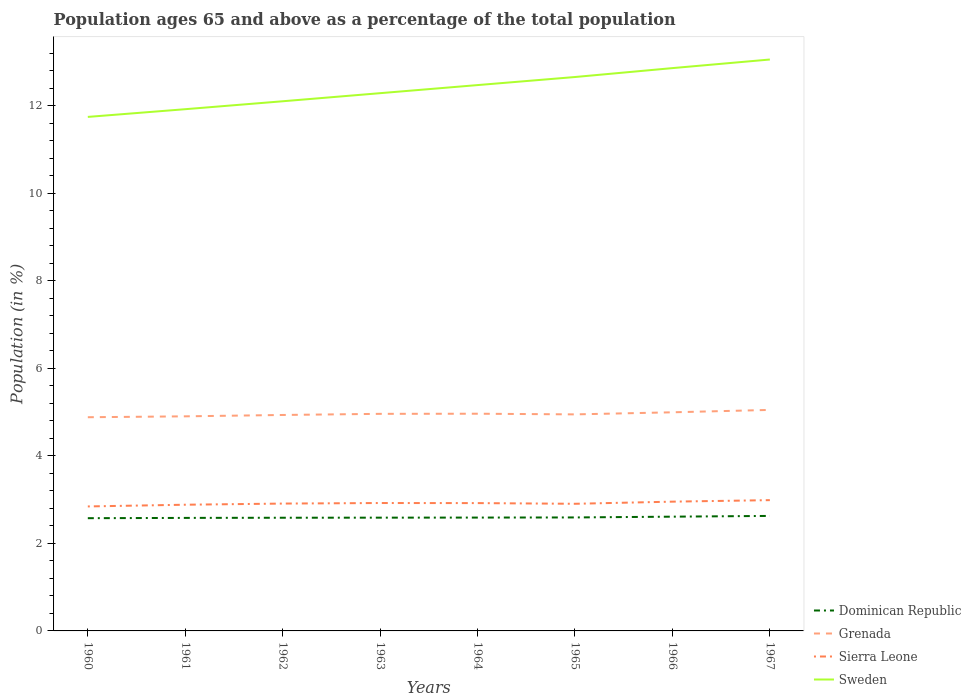How many different coloured lines are there?
Offer a very short reply. 4. Does the line corresponding to Sierra Leone intersect with the line corresponding to Grenada?
Your response must be concise. No. Across all years, what is the maximum percentage of the population ages 65 and above in Grenada?
Keep it short and to the point. 4.88. What is the total percentage of the population ages 65 and above in Sweden in the graph?
Ensure brevity in your answer.  -0.18. What is the difference between the highest and the second highest percentage of the population ages 65 and above in Sweden?
Offer a very short reply. 1.31. Is the percentage of the population ages 65 and above in Sierra Leone strictly greater than the percentage of the population ages 65 and above in Dominican Republic over the years?
Provide a succinct answer. No. How many lines are there?
Provide a short and direct response. 4. How many years are there in the graph?
Keep it short and to the point. 8. Are the values on the major ticks of Y-axis written in scientific E-notation?
Keep it short and to the point. No. Does the graph contain any zero values?
Your response must be concise. No. What is the title of the graph?
Your answer should be very brief. Population ages 65 and above as a percentage of the total population. What is the label or title of the X-axis?
Offer a terse response. Years. What is the label or title of the Y-axis?
Offer a terse response. Population (in %). What is the Population (in %) in Dominican Republic in 1960?
Your answer should be compact. 2.58. What is the Population (in %) in Grenada in 1960?
Keep it short and to the point. 4.88. What is the Population (in %) in Sierra Leone in 1960?
Your answer should be very brief. 2.85. What is the Population (in %) of Sweden in 1960?
Provide a succinct answer. 11.75. What is the Population (in %) of Dominican Republic in 1961?
Ensure brevity in your answer.  2.58. What is the Population (in %) of Grenada in 1961?
Provide a succinct answer. 4.9. What is the Population (in %) in Sierra Leone in 1961?
Your response must be concise. 2.88. What is the Population (in %) of Sweden in 1961?
Provide a succinct answer. 11.92. What is the Population (in %) of Dominican Republic in 1962?
Provide a succinct answer. 2.59. What is the Population (in %) of Grenada in 1962?
Offer a very short reply. 4.94. What is the Population (in %) in Sierra Leone in 1962?
Offer a terse response. 2.91. What is the Population (in %) of Sweden in 1962?
Make the answer very short. 12.11. What is the Population (in %) in Dominican Republic in 1963?
Your answer should be compact. 2.59. What is the Population (in %) of Grenada in 1963?
Keep it short and to the point. 4.96. What is the Population (in %) in Sierra Leone in 1963?
Keep it short and to the point. 2.92. What is the Population (in %) in Sweden in 1963?
Your answer should be very brief. 12.29. What is the Population (in %) in Dominican Republic in 1964?
Make the answer very short. 2.59. What is the Population (in %) in Grenada in 1964?
Your answer should be very brief. 4.96. What is the Population (in %) of Sierra Leone in 1964?
Your response must be concise. 2.92. What is the Population (in %) of Sweden in 1964?
Your answer should be very brief. 12.48. What is the Population (in %) in Dominican Republic in 1965?
Make the answer very short. 2.59. What is the Population (in %) of Grenada in 1965?
Provide a short and direct response. 4.95. What is the Population (in %) in Sierra Leone in 1965?
Ensure brevity in your answer.  2.91. What is the Population (in %) of Sweden in 1965?
Make the answer very short. 12.66. What is the Population (in %) in Dominican Republic in 1966?
Your response must be concise. 2.61. What is the Population (in %) in Grenada in 1966?
Provide a succinct answer. 5. What is the Population (in %) of Sierra Leone in 1966?
Provide a short and direct response. 2.95. What is the Population (in %) of Sweden in 1966?
Keep it short and to the point. 12.86. What is the Population (in %) of Dominican Republic in 1967?
Offer a very short reply. 2.63. What is the Population (in %) in Grenada in 1967?
Provide a succinct answer. 5.05. What is the Population (in %) of Sierra Leone in 1967?
Keep it short and to the point. 2.99. What is the Population (in %) in Sweden in 1967?
Provide a succinct answer. 13.06. Across all years, what is the maximum Population (in %) of Dominican Republic?
Provide a short and direct response. 2.63. Across all years, what is the maximum Population (in %) in Grenada?
Your answer should be very brief. 5.05. Across all years, what is the maximum Population (in %) in Sierra Leone?
Your answer should be very brief. 2.99. Across all years, what is the maximum Population (in %) in Sweden?
Your answer should be compact. 13.06. Across all years, what is the minimum Population (in %) in Dominican Republic?
Give a very brief answer. 2.58. Across all years, what is the minimum Population (in %) in Grenada?
Ensure brevity in your answer.  4.88. Across all years, what is the minimum Population (in %) of Sierra Leone?
Provide a succinct answer. 2.85. Across all years, what is the minimum Population (in %) in Sweden?
Provide a succinct answer. 11.75. What is the total Population (in %) in Dominican Republic in the graph?
Provide a short and direct response. 20.76. What is the total Population (in %) in Grenada in the graph?
Offer a very short reply. 39.65. What is the total Population (in %) in Sierra Leone in the graph?
Ensure brevity in your answer.  23.34. What is the total Population (in %) in Sweden in the graph?
Provide a succinct answer. 99.13. What is the difference between the Population (in %) in Dominican Republic in 1960 and that in 1961?
Make the answer very short. -0.01. What is the difference between the Population (in %) of Grenada in 1960 and that in 1961?
Make the answer very short. -0.02. What is the difference between the Population (in %) of Sierra Leone in 1960 and that in 1961?
Provide a succinct answer. -0.04. What is the difference between the Population (in %) of Sweden in 1960 and that in 1961?
Give a very brief answer. -0.18. What is the difference between the Population (in %) of Dominican Republic in 1960 and that in 1962?
Offer a terse response. -0.01. What is the difference between the Population (in %) in Grenada in 1960 and that in 1962?
Keep it short and to the point. -0.05. What is the difference between the Population (in %) in Sierra Leone in 1960 and that in 1962?
Your answer should be very brief. -0.07. What is the difference between the Population (in %) of Sweden in 1960 and that in 1962?
Make the answer very short. -0.36. What is the difference between the Population (in %) of Dominican Republic in 1960 and that in 1963?
Keep it short and to the point. -0.01. What is the difference between the Population (in %) in Grenada in 1960 and that in 1963?
Make the answer very short. -0.08. What is the difference between the Population (in %) in Sierra Leone in 1960 and that in 1963?
Ensure brevity in your answer.  -0.08. What is the difference between the Population (in %) in Sweden in 1960 and that in 1963?
Provide a short and direct response. -0.54. What is the difference between the Population (in %) in Dominican Republic in 1960 and that in 1964?
Provide a succinct answer. -0.01. What is the difference between the Population (in %) of Grenada in 1960 and that in 1964?
Provide a short and direct response. -0.08. What is the difference between the Population (in %) in Sierra Leone in 1960 and that in 1964?
Give a very brief answer. -0.08. What is the difference between the Population (in %) of Sweden in 1960 and that in 1964?
Your answer should be compact. -0.73. What is the difference between the Population (in %) of Dominican Republic in 1960 and that in 1965?
Provide a short and direct response. -0.02. What is the difference between the Population (in %) in Grenada in 1960 and that in 1965?
Offer a very short reply. -0.07. What is the difference between the Population (in %) in Sierra Leone in 1960 and that in 1965?
Give a very brief answer. -0.06. What is the difference between the Population (in %) in Sweden in 1960 and that in 1965?
Offer a very short reply. -0.91. What is the difference between the Population (in %) in Dominican Republic in 1960 and that in 1966?
Make the answer very short. -0.03. What is the difference between the Population (in %) of Grenada in 1960 and that in 1966?
Provide a short and direct response. -0.11. What is the difference between the Population (in %) of Sierra Leone in 1960 and that in 1966?
Offer a terse response. -0.11. What is the difference between the Population (in %) of Sweden in 1960 and that in 1966?
Your response must be concise. -1.12. What is the difference between the Population (in %) of Dominican Republic in 1960 and that in 1967?
Offer a terse response. -0.05. What is the difference between the Population (in %) of Grenada in 1960 and that in 1967?
Your answer should be compact. -0.17. What is the difference between the Population (in %) of Sierra Leone in 1960 and that in 1967?
Give a very brief answer. -0.14. What is the difference between the Population (in %) in Sweden in 1960 and that in 1967?
Offer a very short reply. -1.31. What is the difference between the Population (in %) of Dominican Republic in 1961 and that in 1962?
Your answer should be very brief. -0. What is the difference between the Population (in %) of Grenada in 1961 and that in 1962?
Your answer should be very brief. -0.03. What is the difference between the Population (in %) of Sierra Leone in 1961 and that in 1962?
Ensure brevity in your answer.  -0.03. What is the difference between the Population (in %) in Sweden in 1961 and that in 1962?
Make the answer very short. -0.18. What is the difference between the Population (in %) in Dominican Republic in 1961 and that in 1963?
Give a very brief answer. -0.01. What is the difference between the Population (in %) in Grenada in 1961 and that in 1963?
Provide a short and direct response. -0.06. What is the difference between the Population (in %) in Sierra Leone in 1961 and that in 1963?
Keep it short and to the point. -0.04. What is the difference between the Population (in %) of Sweden in 1961 and that in 1963?
Your answer should be very brief. -0.37. What is the difference between the Population (in %) in Dominican Republic in 1961 and that in 1964?
Ensure brevity in your answer.  -0.01. What is the difference between the Population (in %) in Grenada in 1961 and that in 1964?
Make the answer very short. -0.06. What is the difference between the Population (in %) of Sierra Leone in 1961 and that in 1964?
Give a very brief answer. -0.04. What is the difference between the Population (in %) of Sweden in 1961 and that in 1964?
Offer a terse response. -0.55. What is the difference between the Population (in %) of Dominican Republic in 1961 and that in 1965?
Your answer should be very brief. -0.01. What is the difference between the Population (in %) of Grenada in 1961 and that in 1965?
Provide a short and direct response. -0.04. What is the difference between the Population (in %) in Sierra Leone in 1961 and that in 1965?
Make the answer very short. -0.02. What is the difference between the Population (in %) of Sweden in 1961 and that in 1965?
Make the answer very short. -0.74. What is the difference between the Population (in %) in Dominican Republic in 1961 and that in 1966?
Provide a short and direct response. -0.03. What is the difference between the Population (in %) in Grenada in 1961 and that in 1966?
Provide a succinct answer. -0.09. What is the difference between the Population (in %) of Sierra Leone in 1961 and that in 1966?
Your answer should be very brief. -0.07. What is the difference between the Population (in %) in Sweden in 1961 and that in 1966?
Give a very brief answer. -0.94. What is the difference between the Population (in %) in Dominican Republic in 1961 and that in 1967?
Your response must be concise. -0.05. What is the difference between the Population (in %) of Grenada in 1961 and that in 1967?
Offer a terse response. -0.15. What is the difference between the Population (in %) of Sierra Leone in 1961 and that in 1967?
Make the answer very short. -0.1. What is the difference between the Population (in %) in Sweden in 1961 and that in 1967?
Your answer should be compact. -1.14. What is the difference between the Population (in %) of Dominican Republic in 1962 and that in 1963?
Your response must be concise. -0. What is the difference between the Population (in %) in Grenada in 1962 and that in 1963?
Your answer should be compact. -0.03. What is the difference between the Population (in %) of Sierra Leone in 1962 and that in 1963?
Offer a very short reply. -0.01. What is the difference between the Population (in %) in Sweden in 1962 and that in 1963?
Provide a succinct answer. -0.18. What is the difference between the Population (in %) in Dominican Republic in 1962 and that in 1964?
Your response must be concise. -0. What is the difference between the Population (in %) in Grenada in 1962 and that in 1964?
Your answer should be very brief. -0.03. What is the difference between the Population (in %) in Sierra Leone in 1962 and that in 1964?
Your response must be concise. -0.01. What is the difference between the Population (in %) of Sweden in 1962 and that in 1964?
Offer a terse response. -0.37. What is the difference between the Population (in %) of Dominican Republic in 1962 and that in 1965?
Keep it short and to the point. -0.01. What is the difference between the Population (in %) in Grenada in 1962 and that in 1965?
Give a very brief answer. -0.01. What is the difference between the Population (in %) in Sierra Leone in 1962 and that in 1965?
Give a very brief answer. 0.01. What is the difference between the Population (in %) in Sweden in 1962 and that in 1965?
Make the answer very short. -0.55. What is the difference between the Population (in %) in Dominican Republic in 1962 and that in 1966?
Give a very brief answer. -0.02. What is the difference between the Population (in %) in Grenada in 1962 and that in 1966?
Your answer should be very brief. -0.06. What is the difference between the Population (in %) of Sierra Leone in 1962 and that in 1966?
Give a very brief answer. -0.04. What is the difference between the Population (in %) of Sweden in 1962 and that in 1966?
Your response must be concise. -0.76. What is the difference between the Population (in %) of Dominican Republic in 1962 and that in 1967?
Keep it short and to the point. -0.04. What is the difference between the Population (in %) of Grenada in 1962 and that in 1967?
Offer a terse response. -0.12. What is the difference between the Population (in %) in Sierra Leone in 1962 and that in 1967?
Provide a short and direct response. -0.08. What is the difference between the Population (in %) in Sweden in 1962 and that in 1967?
Ensure brevity in your answer.  -0.95. What is the difference between the Population (in %) of Dominican Republic in 1963 and that in 1964?
Your answer should be very brief. -0. What is the difference between the Population (in %) in Grenada in 1963 and that in 1964?
Offer a terse response. -0. What is the difference between the Population (in %) in Sierra Leone in 1963 and that in 1964?
Offer a terse response. 0. What is the difference between the Population (in %) in Sweden in 1963 and that in 1964?
Provide a succinct answer. -0.18. What is the difference between the Population (in %) in Dominican Republic in 1963 and that in 1965?
Your answer should be very brief. -0. What is the difference between the Population (in %) of Grenada in 1963 and that in 1965?
Provide a short and direct response. 0.01. What is the difference between the Population (in %) of Sierra Leone in 1963 and that in 1965?
Give a very brief answer. 0.02. What is the difference between the Population (in %) in Sweden in 1963 and that in 1965?
Your answer should be very brief. -0.37. What is the difference between the Population (in %) of Dominican Republic in 1963 and that in 1966?
Your response must be concise. -0.02. What is the difference between the Population (in %) in Grenada in 1963 and that in 1966?
Offer a terse response. -0.04. What is the difference between the Population (in %) of Sierra Leone in 1963 and that in 1966?
Give a very brief answer. -0.03. What is the difference between the Population (in %) of Sweden in 1963 and that in 1966?
Your answer should be compact. -0.57. What is the difference between the Population (in %) in Dominican Republic in 1963 and that in 1967?
Offer a terse response. -0.04. What is the difference between the Population (in %) in Grenada in 1963 and that in 1967?
Ensure brevity in your answer.  -0.09. What is the difference between the Population (in %) in Sierra Leone in 1963 and that in 1967?
Ensure brevity in your answer.  -0.07. What is the difference between the Population (in %) of Sweden in 1963 and that in 1967?
Provide a short and direct response. -0.77. What is the difference between the Population (in %) in Dominican Republic in 1964 and that in 1965?
Provide a succinct answer. -0. What is the difference between the Population (in %) of Grenada in 1964 and that in 1965?
Your answer should be compact. 0.02. What is the difference between the Population (in %) in Sierra Leone in 1964 and that in 1965?
Your response must be concise. 0.02. What is the difference between the Population (in %) in Sweden in 1964 and that in 1965?
Provide a short and direct response. -0.18. What is the difference between the Population (in %) in Dominican Republic in 1964 and that in 1966?
Your answer should be very brief. -0.02. What is the difference between the Population (in %) of Grenada in 1964 and that in 1966?
Offer a terse response. -0.03. What is the difference between the Population (in %) of Sierra Leone in 1964 and that in 1966?
Provide a short and direct response. -0.03. What is the difference between the Population (in %) in Sweden in 1964 and that in 1966?
Your answer should be compact. -0.39. What is the difference between the Population (in %) of Dominican Republic in 1964 and that in 1967?
Make the answer very short. -0.04. What is the difference between the Population (in %) in Grenada in 1964 and that in 1967?
Offer a very short reply. -0.09. What is the difference between the Population (in %) in Sierra Leone in 1964 and that in 1967?
Make the answer very short. -0.07. What is the difference between the Population (in %) of Sweden in 1964 and that in 1967?
Your response must be concise. -0.58. What is the difference between the Population (in %) in Dominican Republic in 1965 and that in 1966?
Keep it short and to the point. -0.02. What is the difference between the Population (in %) of Grenada in 1965 and that in 1966?
Your response must be concise. -0.05. What is the difference between the Population (in %) in Sierra Leone in 1965 and that in 1966?
Keep it short and to the point. -0.05. What is the difference between the Population (in %) of Sweden in 1965 and that in 1966?
Give a very brief answer. -0.2. What is the difference between the Population (in %) of Dominican Republic in 1965 and that in 1967?
Ensure brevity in your answer.  -0.03. What is the difference between the Population (in %) in Grenada in 1965 and that in 1967?
Your answer should be compact. -0.1. What is the difference between the Population (in %) of Sierra Leone in 1965 and that in 1967?
Offer a very short reply. -0.08. What is the difference between the Population (in %) in Sweden in 1965 and that in 1967?
Your answer should be very brief. -0.4. What is the difference between the Population (in %) of Dominican Republic in 1966 and that in 1967?
Make the answer very short. -0.02. What is the difference between the Population (in %) in Grenada in 1966 and that in 1967?
Your answer should be very brief. -0.05. What is the difference between the Population (in %) in Sierra Leone in 1966 and that in 1967?
Provide a short and direct response. -0.03. What is the difference between the Population (in %) in Sweden in 1966 and that in 1967?
Give a very brief answer. -0.2. What is the difference between the Population (in %) in Dominican Republic in 1960 and the Population (in %) in Grenada in 1961?
Give a very brief answer. -2.33. What is the difference between the Population (in %) in Dominican Republic in 1960 and the Population (in %) in Sierra Leone in 1961?
Ensure brevity in your answer.  -0.31. What is the difference between the Population (in %) in Dominican Republic in 1960 and the Population (in %) in Sweden in 1961?
Make the answer very short. -9.35. What is the difference between the Population (in %) in Grenada in 1960 and the Population (in %) in Sierra Leone in 1961?
Make the answer very short. 2. What is the difference between the Population (in %) of Grenada in 1960 and the Population (in %) of Sweden in 1961?
Provide a short and direct response. -7.04. What is the difference between the Population (in %) of Sierra Leone in 1960 and the Population (in %) of Sweden in 1961?
Your answer should be compact. -9.08. What is the difference between the Population (in %) of Dominican Republic in 1960 and the Population (in %) of Grenada in 1962?
Offer a very short reply. -2.36. What is the difference between the Population (in %) of Dominican Republic in 1960 and the Population (in %) of Sierra Leone in 1962?
Your answer should be very brief. -0.33. What is the difference between the Population (in %) in Dominican Republic in 1960 and the Population (in %) in Sweden in 1962?
Provide a succinct answer. -9.53. What is the difference between the Population (in %) of Grenada in 1960 and the Population (in %) of Sierra Leone in 1962?
Your answer should be compact. 1.97. What is the difference between the Population (in %) of Grenada in 1960 and the Population (in %) of Sweden in 1962?
Your response must be concise. -7.22. What is the difference between the Population (in %) in Sierra Leone in 1960 and the Population (in %) in Sweden in 1962?
Your response must be concise. -9.26. What is the difference between the Population (in %) of Dominican Republic in 1960 and the Population (in %) of Grenada in 1963?
Your response must be concise. -2.38. What is the difference between the Population (in %) in Dominican Republic in 1960 and the Population (in %) in Sierra Leone in 1963?
Give a very brief answer. -0.35. What is the difference between the Population (in %) of Dominican Republic in 1960 and the Population (in %) of Sweden in 1963?
Provide a succinct answer. -9.71. What is the difference between the Population (in %) of Grenada in 1960 and the Population (in %) of Sierra Leone in 1963?
Offer a very short reply. 1.96. What is the difference between the Population (in %) of Grenada in 1960 and the Population (in %) of Sweden in 1963?
Give a very brief answer. -7.41. What is the difference between the Population (in %) of Sierra Leone in 1960 and the Population (in %) of Sweden in 1963?
Ensure brevity in your answer.  -9.45. What is the difference between the Population (in %) of Dominican Republic in 1960 and the Population (in %) of Grenada in 1964?
Your answer should be compact. -2.39. What is the difference between the Population (in %) of Dominican Republic in 1960 and the Population (in %) of Sierra Leone in 1964?
Keep it short and to the point. -0.34. What is the difference between the Population (in %) of Dominican Republic in 1960 and the Population (in %) of Sweden in 1964?
Provide a short and direct response. -9.9. What is the difference between the Population (in %) in Grenada in 1960 and the Population (in %) in Sierra Leone in 1964?
Your answer should be compact. 1.96. What is the difference between the Population (in %) in Grenada in 1960 and the Population (in %) in Sweden in 1964?
Your response must be concise. -7.59. What is the difference between the Population (in %) of Sierra Leone in 1960 and the Population (in %) of Sweden in 1964?
Provide a short and direct response. -9.63. What is the difference between the Population (in %) of Dominican Republic in 1960 and the Population (in %) of Grenada in 1965?
Offer a very short reply. -2.37. What is the difference between the Population (in %) of Dominican Republic in 1960 and the Population (in %) of Sierra Leone in 1965?
Provide a short and direct response. -0.33. What is the difference between the Population (in %) of Dominican Republic in 1960 and the Population (in %) of Sweden in 1965?
Keep it short and to the point. -10.08. What is the difference between the Population (in %) in Grenada in 1960 and the Population (in %) in Sierra Leone in 1965?
Ensure brevity in your answer.  1.98. What is the difference between the Population (in %) in Grenada in 1960 and the Population (in %) in Sweden in 1965?
Your answer should be compact. -7.78. What is the difference between the Population (in %) in Sierra Leone in 1960 and the Population (in %) in Sweden in 1965?
Provide a short and direct response. -9.82. What is the difference between the Population (in %) of Dominican Republic in 1960 and the Population (in %) of Grenada in 1966?
Provide a succinct answer. -2.42. What is the difference between the Population (in %) in Dominican Republic in 1960 and the Population (in %) in Sierra Leone in 1966?
Your answer should be compact. -0.38. What is the difference between the Population (in %) in Dominican Republic in 1960 and the Population (in %) in Sweden in 1966?
Offer a terse response. -10.29. What is the difference between the Population (in %) of Grenada in 1960 and the Population (in %) of Sierra Leone in 1966?
Provide a succinct answer. 1.93. What is the difference between the Population (in %) of Grenada in 1960 and the Population (in %) of Sweden in 1966?
Provide a succinct answer. -7.98. What is the difference between the Population (in %) in Sierra Leone in 1960 and the Population (in %) in Sweden in 1966?
Your response must be concise. -10.02. What is the difference between the Population (in %) of Dominican Republic in 1960 and the Population (in %) of Grenada in 1967?
Give a very brief answer. -2.47. What is the difference between the Population (in %) in Dominican Republic in 1960 and the Population (in %) in Sierra Leone in 1967?
Your answer should be very brief. -0.41. What is the difference between the Population (in %) in Dominican Republic in 1960 and the Population (in %) in Sweden in 1967?
Ensure brevity in your answer.  -10.48. What is the difference between the Population (in %) in Grenada in 1960 and the Population (in %) in Sierra Leone in 1967?
Keep it short and to the point. 1.9. What is the difference between the Population (in %) of Grenada in 1960 and the Population (in %) of Sweden in 1967?
Your response must be concise. -8.18. What is the difference between the Population (in %) of Sierra Leone in 1960 and the Population (in %) of Sweden in 1967?
Keep it short and to the point. -10.22. What is the difference between the Population (in %) in Dominican Republic in 1961 and the Population (in %) in Grenada in 1962?
Offer a terse response. -2.35. What is the difference between the Population (in %) of Dominican Republic in 1961 and the Population (in %) of Sierra Leone in 1962?
Keep it short and to the point. -0.33. What is the difference between the Population (in %) in Dominican Republic in 1961 and the Population (in %) in Sweden in 1962?
Provide a succinct answer. -9.52. What is the difference between the Population (in %) of Grenada in 1961 and the Population (in %) of Sierra Leone in 1962?
Your answer should be very brief. 1.99. What is the difference between the Population (in %) of Grenada in 1961 and the Population (in %) of Sweden in 1962?
Ensure brevity in your answer.  -7.2. What is the difference between the Population (in %) of Sierra Leone in 1961 and the Population (in %) of Sweden in 1962?
Your answer should be very brief. -9.22. What is the difference between the Population (in %) in Dominican Republic in 1961 and the Population (in %) in Grenada in 1963?
Offer a terse response. -2.38. What is the difference between the Population (in %) in Dominican Republic in 1961 and the Population (in %) in Sierra Leone in 1963?
Your answer should be very brief. -0.34. What is the difference between the Population (in %) of Dominican Republic in 1961 and the Population (in %) of Sweden in 1963?
Your answer should be very brief. -9.71. What is the difference between the Population (in %) of Grenada in 1961 and the Population (in %) of Sierra Leone in 1963?
Ensure brevity in your answer.  1.98. What is the difference between the Population (in %) of Grenada in 1961 and the Population (in %) of Sweden in 1963?
Your answer should be very brief. -7.39. What is the difference between the Population (in %) in Sierra Leone in 1961 and the Population (in %) in Sweden in 1963?
Your answer should be compact. -9.41. What is the difference between the Population (in %) in Dominican Republic in 1961 and the Population (in %) in Grenada in 1964?
Provide a succinct answer. -2.38. What is the difference between the Population (in %) in Dominican Republic in 1961 and the Population (in %) in Sierra Leone in 1964?
Your answer should be very brief. -0.34. What is the difference between the Population (in %) of Dominican Republic in 1961 and the Population (in %) of Sweden in 1964?
Keep it short and to the point. -9.89. What is the difference between the Population (in %) of Grenada in 1961 and the Population (in %) of Sierra Leone in 1964?
Offer a terse response. 1.98. What is the difference between the Population (in %) of Grenada in 1961 and the Population (in %) of Sweden in 1964?
Offer a very short reply. -7.57. What is the difference between the Population (in %) in Sierra Leone in 1961 and the Population (in %) in Sweden in 1964?
Offer a terse response. -9.59. What is the difference between the Population (in %) in Dominican Republic in 1961 and the Population (in %) in Grenada in 1965?
Give a very brief answer. -2.37. What is the difference between the Population (in %) of Dominican Republic in 1961 and the Population (in %) of Sierra Leone in 1965?
Keep it short and to the point. -0.32. What is the difference between the Population (in %) in Dominican Republic in 1961 and the Population (in %) in Sweden in 1965?
Offer a very short reply. -10.08. What is the difference between the Population (in %) in Grenada in 1961 and the Population (in %) in Sierra Leone in 1965?
Your answer should be compact. 2. What is the difference between the Population (in %) of Grenada in 1961 and the Population (in %) of Sweden in 1965?
Offer a very short reply. -7.76. What is the difference between the Population (in %) in Sierra Leone in 1961 and the Population (in %) in Sweden in 1965?
Provide a short and direct response. -9.78. What is the difference between the Population (in %) in Dominican Republic in 1961 and the Population (in %) in Grenada in 1966?
Your response must be concise. -2.41. What is the difference between the Population (in %) in Dominican Republic in 1961 and the Population (in %) in Sierra Leone in 1966?
Provide a short and direct response. -0.37. What is the difference between the Population (in %) in Dominican Republic in 1961 and the Population (in %) in Sweden in 1966?
Offer a very short reply. -10.28. What is the difference between the Population (in %) of Grenada in 1961 and the Population (in %) of Sierra Leone in 1966?
Your answer should be very brief. 1.95. What is the difference between the Population (in %) in Grenada in 1961 and the Population (in %) in Sweden in 1966?
Your answer should be very brief. -7.96. What is the difference between the Population (in %) in Sierra Leone in 1961 and the Population (in %) in Sweden in 1966?
Offer a very short reply. -9.98. What is the difference between the Population (in %) of Dominican Republic in 1961 and the Population (in %) of Grenada in 1967?
Make the answer very short. -2.47. What is the difference between the Population (in %) of Dominican Republic in 1961 and the Population (in %) of Sierra Leone in 1967?
Offer a very short reply. -0.41. What is the difference between the Population (in %) in Dominican Republic in 1961 and the Population (in %) in Sweden in 1967?
Your response must be concise. -10.48. What is the difference between the Population (in %) of Grenada in 1961 and the Population (in %) of Sierra Leone in 1967?
Offer a terse response. 1.92. What is the difference between the Population (in %) in Grenada in 1961 and the Population (in %) in Sweden in 1967?
Offer a terse response. -8.16. What is the difference between the Population (in %) of Sierra Leone in 1961 and the Population (in %) of Sweden in 1967?
Ensure brevity in your answer.  -10.18. What is the difference between the Population (in %) of Dominican Republic in 1962 and the Population (in %) of Grenada in 1963?
Make the answer very short. -2.37. What is the difference between the Population (in %) of Dominican Republic in 1962 and the Population (in %) of Sierra Leone in 1963?
Provide a short and direct response. -0.34. What is the difference between the Population (in %) in Dominican Republic in 1962 and the Population (in %) in Sweden in 1963?
Your answer should be compact. -9.7. What is the difference between the Population (in %) of Grenada in 1962 and the Population (in %) of Sierra Leone in 1963?
Provide a succinct answer. 2.01. What is the difference between the Population (in %) of Grenada in 1962 and the Population (in %) of Sweden in 1963?
Your answer should be compact. -7.36. What is the difference between the Population (in %) in Sierra Leone in 1962 and the Population (in %) in Sweden in 1963?
Your response must be concise. -9.38. What is the difference between the Population (in %) in Dominican Republic in 1962 and the Population (in %) in Grenada in 1964?
Keep it short and to the point. -2.38. What is the difference between the Population (in %) of Dominican Republic in 1962 and the Population (in %) of Sierra Leone in 1964?
Your response must be concise. -0.33. What is the difference between the Population (in %) in Dominican Republic in 1962 and the Population (in %) in Sweden in 1964?
Keep it short and to the point. -9.89. What is the difference between the Population (in %) of Grenada in 1962 and the Population (in %) of Sierra Leone in 1964?
Your answer should be compact. 2.01. What is the difference between the Population (in %) of Grenada in 1962 and the Population (in %) of Sweden in 1964?
Your answer should be very brief. -7.54. What is the difference between the Population (in %) in Sierra Leone in 1962 and the Population (in %) in Sweden in 1964?
Offer a very short reply. -9.57. What is the difference between the Population (in %) in Dominican Republic in 1962 and the Population (in %) in Grenada in 1965?
Offer a very short reply. -2.36. What is the difference between the Population (in %) in Dominican Republic in 1962 and the Population (in %) in Sierra Leone in 1965?
Keep it short and to the point. -0.32. What is the difference between the Population (in %) in Dominican Republic in 1962 and the Population (in %) in Sweden in 1965?
Provide a succinct answer. -10.07. What is the difference between the Population (in %) in Grenada in 1962 and the Population (in %) in Sierra Leone in 1965?
Your response must be concise. 2.03. What is the difference between the Population (in %) of Grenada in 1962 and the Population (in %) of Sweden in 1965?
Your answer should be compact. -7.72. What is the difference between the Population (in %) of Sierra Leone in 1962 and the Population (in %) of Sweden in 1965?
Give a very brief answer. -9.75. What is the difference between the Population (in %) of Dominican Republic in 1962 and the Population (in %) of Grenada in 1966?
Your answer should be very brief. -2.41. What is the difference between the Population (in %) in Dominican Republic in 1962 and the Population (in %) in Sierra Leone in 1966?
Your response must be concise. -0.37. What is the difference between the Population (in %) of Dominican Republic in 1962 and the Population (in %) of Sweden in 1966?
Ensure brevity in your answer.  -10.28. What is the difference between the Population (in %) of Grenada in 1962 and the Population (in %) of Sierra Leone in 1966?
Make the answer very short. 1.98. What is the difference between the Population (in %) in Grenada in 1962 and the Population (in %) in Sweden in 1966?
Offer a terse response. -7.93. What is the difference between the Population (in %) in Sierra Leone in 1962 and the Population (in %) in Sweden in 1966?
Offer a very short reply. -9.95. What is the difference between the Population (in %) of Dominican Republic in 1962 and the Population (in %) of Grenada in 1967?
Your answer should be very brief. -2.46. What is the difference between the Population (in %) of Dominican Republic in 1962 and the Population (in %) of Sierra Leone in 1967?
Provide a succinct answer. -0.4. What is the difference between the Population (in %) of Dominican Republic in 1962 and the Population (in %) of Sweden in 1967?
Provide a short and direct response. -10.47. What is the difference between the Population (in %) in Grenada in 1962 and the Population (in %) in Sierra Leone in 1967?
Keep it short and to the point. 1.95. What is the difference between the Population (in %) of Grenada in 1962 and the Population (in %) of Sweden in 1967?
Offer a very short reply. -8.12. What is the difference between the Population (in %) of Sierra Leone in 1962 and the Population (in %) of Sweden in 1967?
Provide a short and direct response. -10.15. What is the difference between the Population (in %) of Dominican Republic in 1963 and the Population (in %) of Grenada in 1964?
Your answer should be compact. -2.38. What is the difference between the Population (in %) of Dominican Republic in 1963 and the Population (in %) of Sierra Leone in 1964?
Make the answer very short. -0.33. What is the difference between the Population (in %) of Dominican Republic in 1963 and the Population (in %) of Sweden in 1964?
Provide a succinct answer. -9.89. What is the difference between the Population (in %) in Grenada in 1963 and the Population (in %) in Sierra Leone in 1964?
Ensure brevity in your answer.  2.04. What is the difference between the Population (in %) of Grenada in 1963 and the Population (in %) of Sweden in 1964?
Make the answer very short. -7.51. What is the difference between the Population (in %) of Sierra Leone in 1963 and the Population (in %) of Sweden in 1964?
Give a very brief answer. -9.55. What is the difference between the Population (in %) in Dominican Republic in 1963 and the Population (in %) in Grenada in 1965?
Your answer should be very brief. -2.36. What is the difference between the Population (in %) in Dominican Republic in 1963 and the Population (in %) in Sierra Leone in 1965?
Keep it short and to the point. -0.32. What is the difference between the Population (in %) of Dominican Republic in 1963 and the Population (in %) of Sweden in 1965?
Make the answer very short. -10.07. What is the difference between the Population (in %) in Grenada in 1963 and the Population (in %) in Sierra Leone in 1965?
Give a very brief answer. 2.06. What is the difference between the Population (in %) in Grenada in 1963 and the Population (in %) in Sweden in 1965?
Ensure brevity in your answer.  -7.7. What is the difference between the Population (in %) of Sierra Leone in 1963 and the Population (in %) of Sweden in 1965?
Your answer should be very brief. -9.74. What is the difference between the Population (in %) of Dominican Republic in 1963 and the Population (in %) of Grenada in 1966?
Provide a short and direct response. -2.41. What is the difference between the Population (in %) in Dominican Republic in 1963 and the Population (in %) in Sierra Leone in 1966?
Your answer should be compact. -0.37. What is the difference between the Population (in %) in Dominican Republic in 1963 and the Population (in %) in Sweden in 1966?
Your answer should be very brief. -10.28. What is the difference between the Population (in %) in Grenada in 1963 and the Population (in %) in Sierra Leone in 1966?
Your answer should be very brief. 2.01. What is the difference between the Population (in %) of Grenada in 1963 and the Population (in %) of Sweden in 1966?
Offer a terse response. -7.9. What is the difference between the Population (in %) of Sierra Leone in 1963 and the Population (in %) of Sweden in 1966?
Your answer should be compact. -9.94. What is the difference between the Population (in %) in Dominican Republic in 1963 and the Population (in %) in Grenada in 1967?
Your answer should be very brief. -2.46. What is the difference between the Population (in %) of Dominican Republic in 1963 and the Population (in %) of Sierra Leone in 1967?
Your answer should be very brief. -0.4. What is the difference between the Population (in %) in Dominican Republic in 1963 and the Population (in %) in Sweden in 1967?
Ensure brevity in your answer.  -10.47. What is the difference between the Population (in %) of Grenada in 1963 and the Population (in %) of Sierra Leone in 1967?
Keep it short and to the point. 1.97. What is the difference between the Population (in %) of Grenada in 1963 and the Population (in %) of Sweden in 1967?
Your answer should be compact. -8.1. What is the difference between the Population (in %) of Sierra Leone in 1963 and the Population (in %) of Sweden in 1967?
Offer a terse response. -10.14. What is the difference between the Population (in %) in Dominican Republic in 1964 and the Population (in %) in Grenada in 1965?
Keep it short and to the point. -2.36. What is the difference between the Population (in %) in Dominican Republic in 1964 and the Population (in %) in Sierra Leone in 1965?
Offer a very short reply. -0.32. What is the difference between the Population (in %) of Dominican Republic in 1964 and the Population (in %) of Sweden in 1965?
Ensure brevity in your answer.  -10.07. What is the difference between the Population (in %) in Grenada in 1964 and the Population (in %) in Sierra Leone in 1965?
Provide a short and direct response. 2.06. What is the difference between the Population (in %) in Grenada in 1964 and the Population (in %) in Sweden in 1965?
Provide a short and direct response. -7.7. What is the difference between the Population (in %) in Sierra Leone in 1964 and the Population (in %) in Sweden in 1965?
Ensure brevity in your answer.  -9.74. What is the difference between the Population (in %) of Dominican Republic in 1964 and the Population (in %) of Grenada in 1966?
Offer a terse response. -2.41. What is the difference between the Population (in %) in Dominican Republic in 1964 and the Population (in %) in Sierra Leone in 1966?
Keep it short and to the point. -0.36. What is the difference between the Population (in %) in Dominican Republic in 1964 and the Population (in %) in Sweden in 1966?
Your answer should be very brief. -10.27. What is the difference between the Population (in %) of Grenada in 1964 and the Population (in %) of Sierra Leone in 1966?
Ensure brevity in your answer.  2.01. What is the difference between the Population (in %) in Grenada in 1964 and the Population (in %) in Sweden in 1966?
Your answer should be very brief. -7.9. What is the difference between the Population (in %) of Sierra Leone in 1964 and the Population (in %) of Sweden in 1966?
Your answer should be very brief. -9.94. What is the difference between the Population (in %) of Dominican Republic in 1964 and the Population (in %) of Grenada in 1967?
Your response must be concise. -2.46. What is the difference between the Population (in %) in Dominican Republic in 1964 and the Population (in %) in Sierra Leone in 1967?
Your answer should be compact. -0.4. What is the difference between the Population (in %) in Dominican Republic in 1964 and the Population (in %) in Sweden in 1967?
Your answer should be very brief. -10.47. What is the difference between the Population (in %) in Grenada in 1964 and the Population (in %) in Sierra Leone in 1967?
Your response must be concise. 1.98. What is the difference between the Population (in %) of Grenada in 1964 and the Population (in %) of Sweden in 1967?
Give a very brief answer. -8.1. What is the difference between the Population (in %) in Sierra Leone in 1964 and the Population (in %) in Sweden in 1967?
Offer a very short reply. -10.14. What is the difference between the Population (in %) of Dominican Republic in 1965 and the Population (in %) of Grenada in 1966?
Your response must be concise. -2.4. What is the difference between the Population (in %) of Dominican Republic in 1965 and the Population (in %) of Sierra Leone in 1966?
Give a very brief answer. -0.36. What is the difference between the Population (in %) of Dominican Republic in 1965 and the Population (in %) of Sweden in 1966?
Offer a terse response. -10.27. What is the difference between the Population (in %) of Grenada in 1965 and the Population (in %) of Sierra Leone in 1966?
Your answer should be very brief. 1.99. What is the difference between the Population (in %) of Grenada in 1965 and the Population (in %) of Sweden in 1966?
Your answer should be very brief. -7.91. What is the difference between the Population (in %) in Sierra Leone in 1965 and the Population (in %) in Sweden in 1966?
Give a very brief answer. -9.96. What is the difference between the Population (in %) of Dominican Republic in 1965 and the Population (in %) of Grenada in 1967?
Offer a terse response. -2.46. What is the difference between the Population (in %) of Dominican Republic in 1965 and the Population (in %) of Sierra Leone in 1967?
Your answer should be very brief. -0.4. What is the difference between the Population (in %) in Dominican Republic in 1965 and the Population (in %) in Sweden in 1967?
Your response must be concise. -10.47. What is the difference between the Population (in %) of Grenada in 1965 and the Population (in %) of Sierra Leone in 1967?
Make the answer very short. 1.96. What is the difference between the Population (in %) of Grenada in 1965 and the Population (in %) of Sweden in 1967?
Your answer should be compact. -8.11. What is the difference between the Population (in %) of Sierra Leone in 1965 and the Population (in %) of Sweden in 1967?
Your answer should be very brief. -10.15. What is the difference between the Population (in %) of Dominican Republic in 1966 and the Population (in %) of Grenada in 1967?
Give a very brief answer. -2.44. What is the difference between the Population (in %) in Dominican Republic in 1966 and the Population (in %) in Sierra Leone in 1967?
Make the answer very short. -0.38. What is the difference between the Population (in %) of Dominican Republic in 1966 and the Population (in %) of Sweden in 1967?
Offer a terse response. -10.45. What is the difference between the Population (in %) in Grenada in 1966 and the Population (in %) in Sierra Leone in 1967?
Make the answer very short. 2.01. What is the difference between the Population (in %) of Grenada in 1966 and the Population (in %) of Sweden in 1967?
Offer a very short reply. -8.06. What is the difference between the Population (in %) in Sierra Leone in 1966 and the Population (in %) in Sweden in 1967?
Make the answer very short. -10.11. What is the average Population (in %) in Dominican Republic per year?
Offer a very short reply. 2.6. What is the average Population (in %) in Grenada per year?
Offer a very short reply. 4.96. What is the average Population (in %) in Sierra Leone per year?
Offer a very short reply. 2.92. What is the average Population (in %) in Sweden per year?
Ensure brevity in your answer.  12.39. In the year 1960, what is the difference between the Population (in %) of Dominican Republic and Population (in %) of Grenada?
Provide a succinct answer. -2.31. In the year 1960, what is the difference between the Population (in %) in Dominican Republic and Population (in %) in Sierra Leone?
Your answer should be compact. -0.27. In the year 1960, what is the difference between the Population (in %) of Dominican Republic and Population (in %) of Sweden?
Offer a very short reply. -9.17. In the year 1960, what is the difference between the Population (in %) of Grenada and Population (in %) of Sierra Leone?
Ensure brevity in your answer.  2.04. In the year 1960, what is the difference between the Population (in %) in Grenada and Population (in %) in Sweden?
Give a very brief answer. -6.86. In the year 1960, what is the difference between the Population (in %) of Sierra Leone and Population (in %) of Sweden?
Provide a short and direct response. -8.9. In the year 1961, what is the difference between the Population (in %) in Dominican Republic and Population (in %) in Grenada?
Provide a succinct answer. -2.32. In the year 1961, what is the difference between the Population (in %) of Dominican Republic and Population (in %) of Sierra Leone?
Ensure brevity in your answer.  -0.3. In the year 1961, what is the difference between the Population (in %) in Dominican Republic and Population (in %) in Sweden?
Your answer should be compact. -9.34. In the year 1961, what is the difference between the Population (in %) in Grenada and Population (in %) in Sierra Leone?
Make the answer very short. 2.02. In the year 1961, what is the difference between the Population (in %) in Grenada and Population (in %) in Sweden?
Provide a short and direct response. -7.02. In the year 1961, what is the difference between the Population (in %) of Sierra Leone and Population (in %) of Sweden?
Give a very brief answer. -9.04. In the year 1962, what is the difference between the Population (in %) in Dominican Republic and Population (in %) in Grenada?
Make the answer very short. -2.35. In the year 1962, what is the difference between the Population (in %) of Dominican Republic and Population (in %) of Sierra Leone?
Provide a short and direct response. -0.32. In the year 1962, what is the difference between the Population (in %) of Dominican Republic and Population (in %) of Sweden?
Your response must be concise. -9.52. In the year 1962, what is the difference between the Population (in %) in Grenada and Population (in %) in Sierra Leone?
Your answer should be very brief. 2.03. In the year 1962, what is the difference between the Population (in %) of Grenada and Population (in %) of Sweden?
Offer a very short reply. -7.17. In the year 1962, what is the difference between the Population (in %) in Sierra Leone and Population (in %) in Sweden?
Give a very brief answer. -9.2. In the year 1963, what is the difference between the Population (in %) of Dominican Republic and Population (in %) of Grenada?
Your answer should be very brief. -2.37. In the year 1963, what is the difference between the Population (in %) of Dominican Republic and Population (in %) of Sierra Leone?
Your answer should be compact. -0.33. In the year 1963, what is the difference between the Population (in %) in Dominican Republic and Population (in %) in Sweden?
Give a very brief answer. -9.7. In the year 1963, what is the difference between the Population (in %) of Grenada and Population (in %) of Sierra Leone?
Offer a very short reply. 2.04. In the year 1963, what is the difference between the Population (in %) of Grenada and Population (in %) of Sweden?
Your answer should be compact. -7.33. In the year 1963, what is the difference between the Population (in %) in Sierra Leone and Population (in %) in Sweden?
Ensure brevity in your answer.  -9.37. In the year 1964, what is the difference between the Population (in %) of Dominican Republic and Population (in %) of Grenada?
Keep it short and to the point. -2.37. In the year 1964, what is the difference between the Population (in %) of Dominican Republic and Population (in %) of Sierra Leone?
Provide a succinct answer. -0.33. In the year 1964, what is the difference between the Population (in %) in Dominican Republic and Population (in %) in Sweden?
Your answer should be compact. -9.89. In the year 1964, what is the difference between the Population (in %) of Grenada and Population (in %) of Sierra Leone?
Your response must be concise. 2.04. In the year 1964, what is the difference between the Population (in %) of Grenada and Population (in %) of Sweden?
Your answer should be very brief. -7.51. In the year 1964, what is the difference between the Population (in %) in Sierra Leone and Population (in %) in Sweden?
Give a very brief answer. -9.55. In the year 1965, what is the difference between the Population (in %) of Dominican Republic and Population (in %) of Grenada?
Provide a succinct answer. -2.36. In the year 1965, what is the difference between the Population (in %) of Dominican Republic and Population (in %) of Sierra Leone?
Your answer should be very brief. -0.31. In the year 1965, what is the difference between the Population (in %) in Dominican Republic and Population (in %) in Sweden?
Offer a terse response. -10.07. In the year 1965, what is the difference between the Population (in %) in Grenada and Population (in %) in Sierra Leone?
Provide a short and direct response. 2.04. In the year 1965, what is the difference between the Population (in %) in Grenada and Population (in %) in Sweden?
Your answer should be compact. -7.71. In the year 1965, what is the difference between the Population (in %) of Sierra Leone and Population (in %) of Sweden?
Offer a very short reply. -9.75. In the year 1966, what is the difference between the Population (in %) of Dominican Republic and Population (in %) of Grenada?
Your answer should be compact. -2.39. In the year 1966, what is the difference between the Population (in %) in Dominican Republic and Population (in %) in Sierra Leone?
Provide a succinct answer. -0.34. In the year 1966, what is the difference between the Population (in %) in Dominican Republic and Population (in %) in Sweden?
Your answer should be compact. -10.25. In the year 1966, what is the difference between the Population (in %) of Grenada and Population (in %) of Sierra Leone?
Keep it short and to the point. 2.04. In the year 1966, what is the difference between the Population (in %) in Grenada and Population (in %) in Sweden?
Provide a short and direct response. -7.87. In the year 1966, what is the difference between the Population (in %) of Sierra Leone and Population (in %) of Sweden?
Ensure brevity in your answer.  -9.91. In the year 1967, what is the difference between the Population (in %) in Dominican Republic and Population (in %) in Grenada?
Provide a short and direct response. -2.42. In the year 1967, what is the difference between the Population (in %) of Dominican Republic and Population (in %) of Sierra Leone?
Offer a terse response. -0.36. In the year 1967, what is the difference between the Population (in %) of Dominican Republic and Population (in %) of Sweden?
Offer a terse response. -10.43. In the year 1967, what is the difference between the Population (in %) in Grenada and Population (in %) in Sierra Leone?
Keep it short and to the point. 2.06. In the year 1967, what is the difference between the Population (in %) of Grenada and Population (in %) of Sweden?
Ensure brevity in your answer.  -8.01. In the year 1967, what is the difference between the Population (in %) of Sierra Leone and Population (in %) of Sweden?
Your answer should be very brief. -10.07. What is the ratio of the Population (in %) in Dominican Republic in 1960 to that in 1961?
Give a very brief answer. 1. What is the ratio of the Population (in %) in Grenada in 1960 to that in 1961?
Keep it short and to the point. 1. What is the ratio of the Population (in %) of Sierra Leone in 1960 to that in 1961?
Make the answer very short. 0.99. What is the ratio of the Population (in %) in Sweden in 1960 to that in 1961?
Your response must be concise. 0.99. What is the ratio of the Population (in %) of Sierra Leone in 1960 to that in 1962?
Make the answer very short. 0.98. What is the ratio of the Population (in %) of Sweden in 1960 to that in 1962?
Provide a short and direct response. 0.97. What is the ratio of the Population (in %) of Dominican Republic in 1960 to that in 1963?
Ensure brevity in your answer.  1. What is the ratio of the Population (in %) in Grenada in 1960 to that in 1963?
Offer a very short reply. 0.98. What is the ratio of the Population (in %) of Sierra Leone in 1960 to that in 1963?
Offer a very short reply. 0.97. What is the ratio of the Population (in %) in Sweden in 1960 to that in 1963?
Ensure brevity in your answer.  0.96. What is the ratio of the Population (in %) in Dominican Republic in 1960 to that in 1964?
Offer a terse response. 0.99. What is the ratio of the Population (in %) in Grenada in 1960 to that in 1964?
Your answer should be compact. 0.98. What is the ratio of the Population (in %) in Sierra Leone in 1960 to that in 1964?
Offer a terse response. 0.97. What is the ratio of the Population (in %) in Sweden in 1960 to that in 1964?
Your response must be concise. 0.94. What is the ratio of the Population (in %) in Sierra Leone in 1960 to that in 1965?
Offer a very short reply. 0.98. What is the ratio of the Population (in %) of Sweden in 1960 to that in 1965?
Keep it short and to the point. 0.93. What is the ratio of the Population (in %) in Dominican Republic in 1960 to that in 1966?
Keep it short and to the point. 0.99. What is the ratio of the Population (in %) in Grenada in 1960 to that in 1966?
Keep it short and to the point. 0.98. What is the ratio of the Population (in %) of Sierra Leone in 1960 to that in 1966?
Ensure brevity in your answer.  0.96. What is the ratio of the Population (in %) in Sweden in 1960 to that in 1966?
Make the answer very short. 0.91. What is the ratio of the Population (in %) of Dominican Republic in 1960 to that in 1967?
Offer a very short reply. 0.98. What is the ratio of the Population (in %) in Grenada in 1960 to that in 1967?
Your answer should be compact. 0.97. What is the ratio of the Population (in %) of Sierra Leone in 1960 to that in 1967?
Give a very brief answer. 0.95. What is the ratio of the Population (in %) of Sweden in 1960 to that in 1967?
Ensure brevity in your answer.  0.9. What is the ratio of the Population (in %) of Grenada in 1961 to that in 1962?
Ensure brevity in your answer.  0.99. What is the ratio of the Population (in %) in Sierra Leone in 1961 to that in 1962?
Your response must be concise. 0.99. What is the ratio of the Population (in %) of Sweden in 1961 to that in 1962?
Your response must be concise. 0.98. What is the ratio of the Population (in %) of Dominican Republic in 1961 to that in 1963?
Ensure brevity in your answer.  1. What is the ratio of the Population (in %) in Sierra Leone in 1961 to that in 1963?
Your answer should be very brief. 0.99. What is the ratio of the Population (in %) of Sweden in 1961 to that in 1963?
Make the answer very short. 0.97. What is the ratio of the Population (in %) of Grenada in 1961 to that in 1964?
Give a very brief answer. 0.99. What is the ratio of the Population (in %) of Sierra Leone in 1961 to that in 1964?
Keep it short and to the point. 0.99. What is the ratio of the Population (in %) of Sweden in 1961 to that in 1964?
Give a very brief answer. 0.96. What is the ratio of the Population (in %) in Dominican Republic in 1961 to that in 1965?
Make the answer very short. 1. What is the ratio of the Population (in %) in Sierra Leone in 1961 to that in 1965?
Your response must be concise. 0.99. What is the ratio of the Population (in %) of Sweden in 1961 to that in 1965?
Your answer should be compact. 0.94. What is the ratio of the Population (in %) of Grenada in 1961 to that in 1966?
Keep it short and to the point. 0.98. What is the ratio of the Population (in %) of Sierra Leone in 1961 to that in 1966?
Keep it short and to the point. 0.98. What is the ratio of the Population (in %) in Sweden in 1961 to that in 1966?
Keep it short and to the point. 0.93. What is the ratio of the Population (in %) in Dominican Republic in 1961 to that in 1967?
Provide a short and direct response. 0.98. What is the ratio of the Population (in %) of Grenada in 1961 to that in 1967?
Your answer should be compact. 0.97. What is the ratio of the Population (in %) in Dominican Republic in 1962 to that in 1963?
Offer a very short reply. 1. What is the ratio of the Population (in %) in Grenada in 1962 to that in 1963?
Provide a short and direct response. 0.99. What is the ratio of the Population (in %) in Sierra Leone in 1962 to that in 1963?
Your answer should be very brief. 1. What is the ratio of the Population (in %) of Dominican Republic in 1962 to that in 1964?
Give a very brief answer. 1. What is the ratio of the Population (in %) in Grenada in 1962 to that in 1964?
Make the answer very short. 0.99. What is the ratio of the Population (in %) of Sierra Leone in 1962 to that in 1964?
Offer a very short reply. 1. What is the ratio of the Population (in %) of Sweden in 1962 to that in 1964?
Ensure brevity in your answer.  0.97. What is the ratio of the Population (in %) of Sweden in 1962 to that in 1965?
Offer a very short reply. 0.96. What is the ratio of the Population (in %) of Sierra Leone in 1962 to that in 1966?
Provide a short and direct response. 0.99. What is the ratio of the Population (in %) of Sweden in 1962 to that in 1966?
Provide a short and direct response. 0.94. What is the ratio of the Population (in %) of Dominican Republic in 1962 to that in 1967?
Offer a very short reply. 0.98. What is the ratio of the Population (in %) of Grenada in 1962 to that in 1967?
Keep it short and to the point. 0.98. What is the ratio of the Population (in %) in Sierra Leone in 1962 to that in 1967?
Provide a short and direct response. 0.97. What is the ratio of the Population (in %) in Sweden in 1962 to that in 1967?
Make the answer very short. 0.93. What is the ratio of the Population (in %) of Dominican Republic in 1963 to that in 1964?
Give a very brief answer. 1. What is the ratio of the Population (in %) of Sweden in 1963 to that in 1964?
Your answer should be compact. 0.99. What is the ratio of the Population (in %) in Sierra Leone in 1963 to that in 1965?
Ensure brevity in your answer.  1.01. What is the ratio of the Population (in %) of Sweden in 1963 to that in 1965?
Offer a terse response. 0.97. What is the ratio of the Population (in %) of Sierra Leone in 1963 to that in 1966?
Keep it short and to the point. 0.99. What is the ratio of the Population (in %) in Sweden in 1963 to that in 1966?
Provide a succinct answer. 0.96. What is the ratio of the Population (in %) in Dominican Republic in 1963 to that in 1967?
Your answer should be very brief. 0.98. What is the ratio of the Population (in %) in Grenada in 1963 to that in 1967?
Give a very brief answer. 0.98. What is the ratio of the Population (in %) in Sweden in 1963 to that in 1967?
Keep it short and to the point. 0.94. What is the ratio of the Population (in %) of Dominican Republic in 1964 to that in 1965?
Your answer should be very brief. 1. What is the ratio of the Population (in %) in Sierra Leone in 1964 to that in 1965?
Give a very brief answer. 1.01. What is the ratio of the Population (in %) in Sweden in 1964 to that in 1965?
Make the answer very short. 0.99. What is the ratio of the Population (in %) in Dominican Republic in 1964 to that in 1966?
Your answer should be compact. 0.99. What is the ratio of the Population (in %) of Grenada in 1964 to that in 1966?
Provide a short and direct response. 0.99. What is the ratio of the Population (in %) of Sweden in 1964 to that in 1966?
Offer a terse response. 0.97. What is the ratio of the Population (in %) of Dominican Republic in 1964 to that in 1967?
Give a very brief answer. 0.99. What is the ratio of the Population (in %) in Grenada in 1964 to that in 1967?
Make the answer very short. 0.98. What is the ratio of the Population (in %) of Sierra Leone in 1964 to that in 1967?
Keep it short and to the point. 0.98. What is the ratio of the Population (in %) of Sweden in 1964 to that in 1967?
Give a very brief answer. 0.96. What is the ratio of the Population (in %) of Dominican Republic in 1965 to that in 1966?
Your answer should be compact. 0.99. What is the ratio of the Population (in %) of Grenada in 1965 to that in 1966?
Ensure brevity in your answer.  0.99. What is the ratio of the Population (in %) in Sierra Leone in 1965 to that in 1966?
Ensure brevity in your answer.  0.98. What is the ratio of the Population (in %) of Sweden in 1965 to that in 1966?
Offer a terse response. 0.98. What is the ratio of the Population (in %) in Dominican Republic in 1965 to that in 1967?
Offer a terse response. 0.99. What is the ratio of the Population (in %) of Grenada in 1965 to that in 1967?
Keep it short and to the point. 0.98. What is the ratio of the Population (in %) in Sierra Leone in 1965 to that in 1967?
Your response must be concise. 0.97. What is the ratio of the Population (in %) of Sweden in 1965 to that in 1967?
Your response must be concise. 0.97. What is the ratio of the Population (in %) of Dominican Republic in 1966 to that in 1967?
Offer a very short reply. 0.99. What is the ratio of the Population (in %) in Sierra Leone in 1966 to that in 1967?
Offer a terse response. 0.99. What is the difference between the highest and the second highest Population (in %) of Dominican Republic?
Your answer should be very brief. 0.02. What is the difference between the highest and the second highest Population (in %) of Grenada?
Provide a short and direct response. 0.05. What is the difference between the highest and the second highest Population (in %) of Sierra Leone?
Provide a short and direct response. 0.03. What is the difference between the highest and the second highest Population (in %) of Sweden?
Ensure brevity in your answer.  0.2. What is the difference between the highest and the lowest Population (in %) of Dominican Republic?
Keep it short and to the point. 0.05. What is the difference between the highest and the lowest Population (in %) in Grenada?
Make the answer very short. 0.17. What is the difference between the highest and the lowest Population (in %) in Sierra Leone?
Make the answer very short. 0.14. What is the difference between the highest and the lowest Population (in %) in Sweden?
Provide a succinct answer. 1.31. 